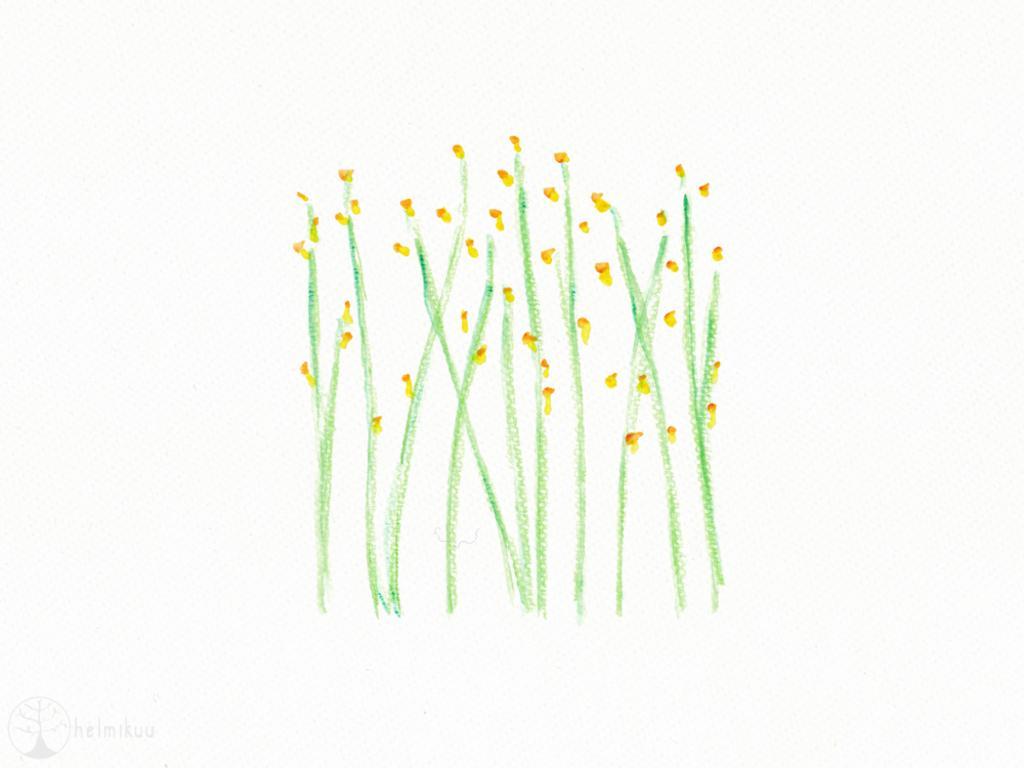Could you give a brief overview of what you see in this image? This is the picture of a drawing in which there are some plants to which there are some flowers. 